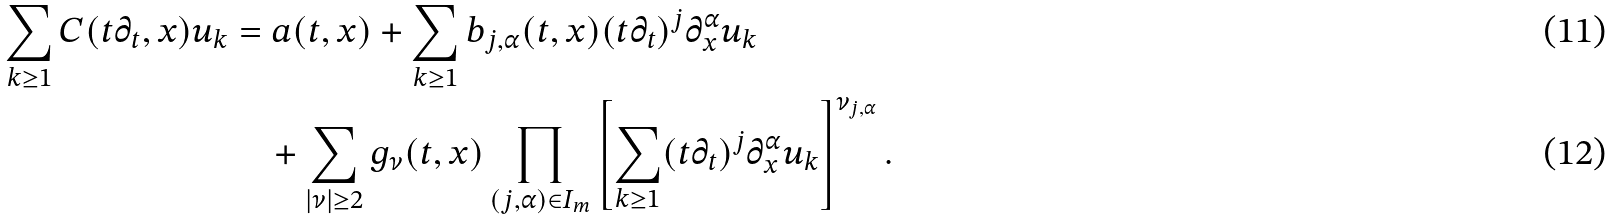Convert formula to latex. <formula><loc_0><loc_0><loc_500><loc_500>\sum _ { k \geq 1 } C ( t \partial _ { t } , x ) u _ { k } & = a ( t , x ) + \sum _ { k \geq 1 } b _ { j , \alpha } ( t , x ) ( t \partial _ { t } ) ^ { j } \partial _ { x } ^ { \alpha } u _ { k } \\ & \quad + \sum _ { | \nu | \geq 2 } g _ { \nu } ( t , x ) \prod _ { ( j , \alpha ) \in I _ { m } } \left [ \sum _ { k \geq 1 } ( t \partial _ { t } ) ^ { j } \partial _ { x } ^ { \alpha } u _ { k } \right ] ^ { \nu _ { j , \alpha } } .</formula> 